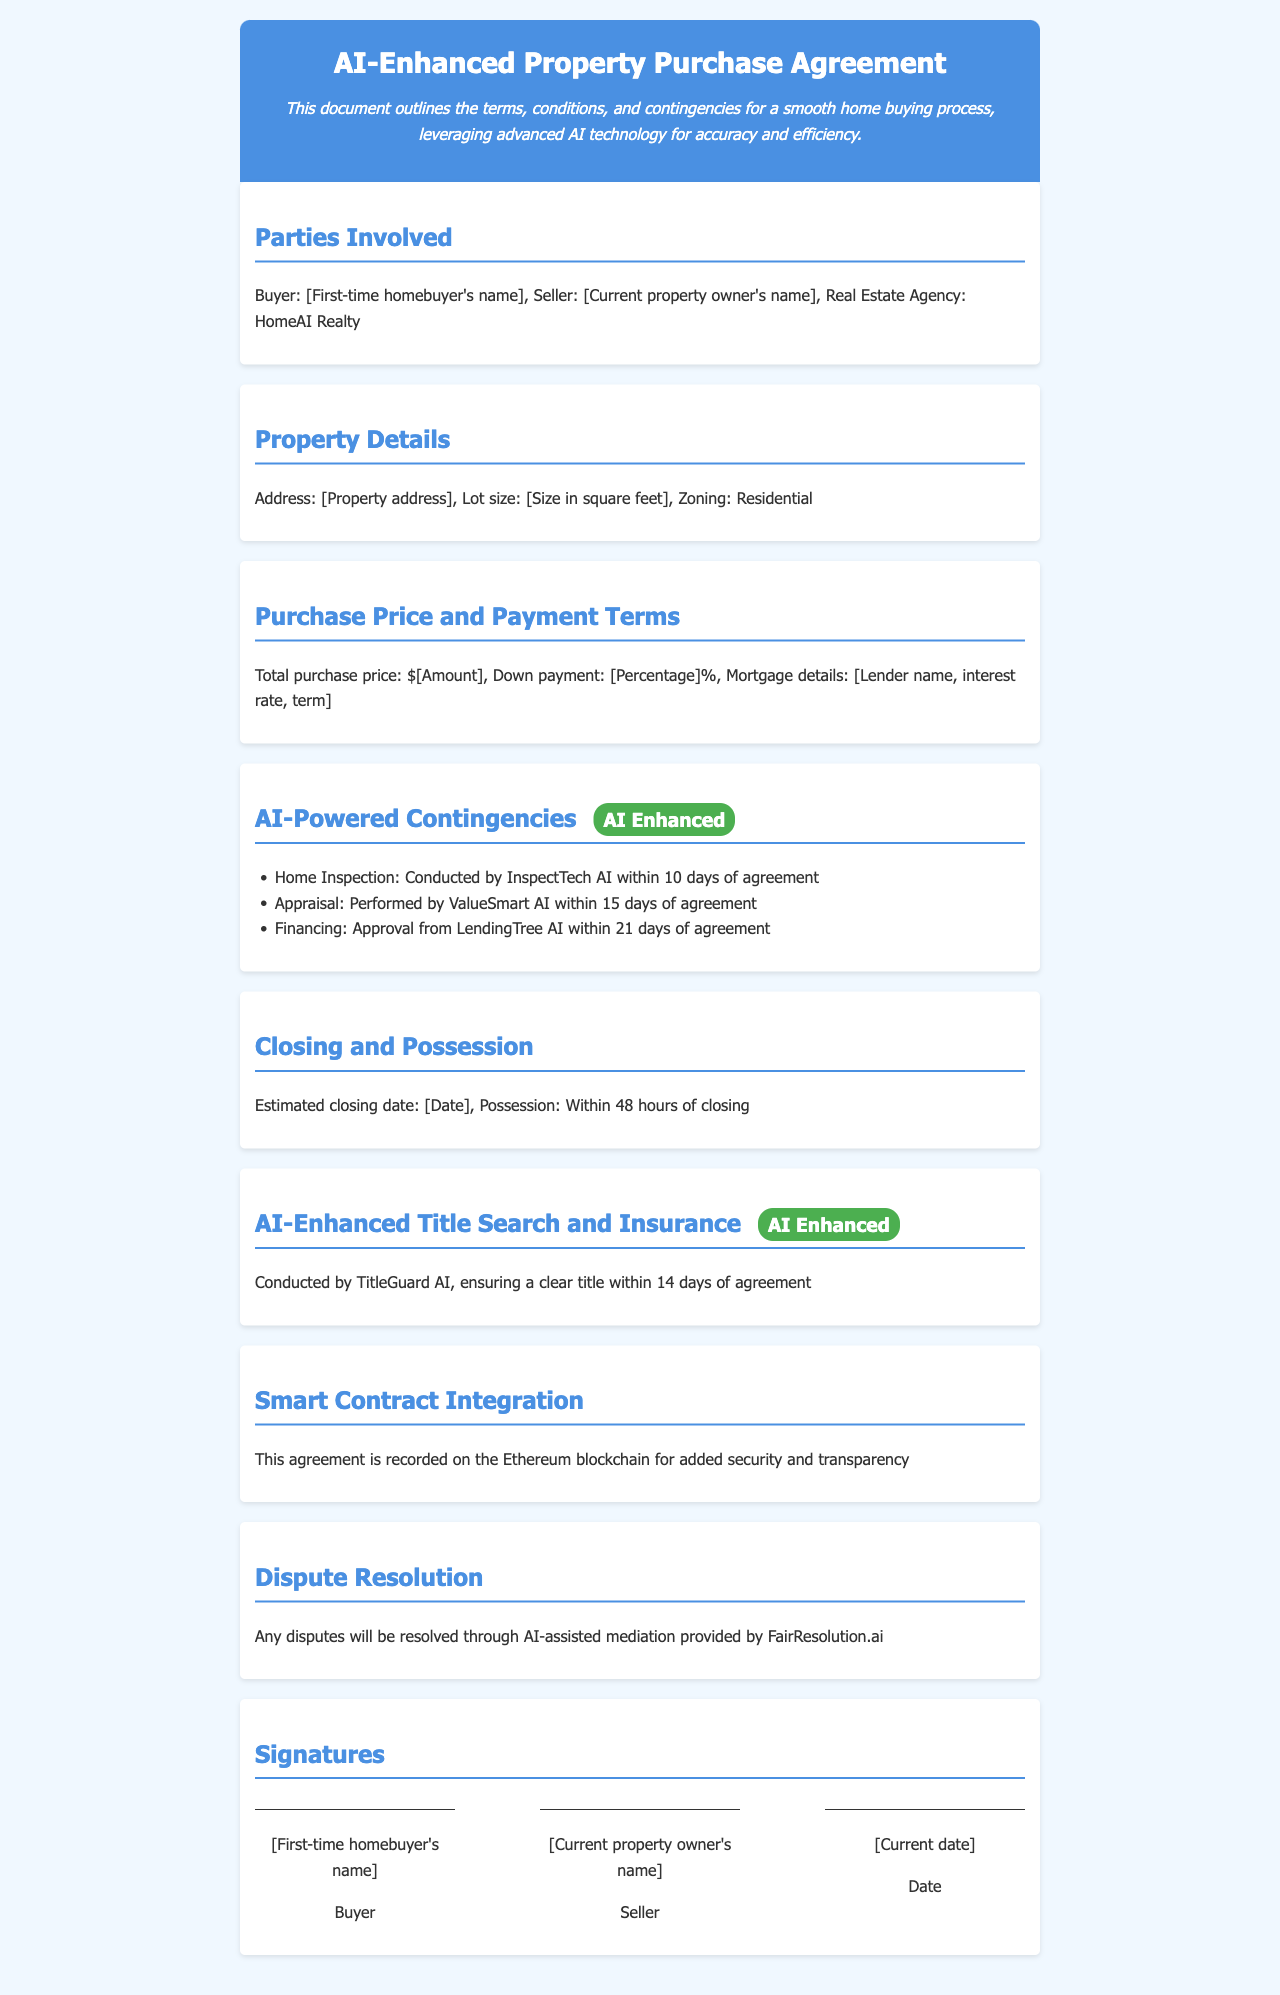What is the buyer's name? The document mentions the buyer as "[First-time homebuyer's name]", indicating the identity of the buyer.
Answer: [First-time homebuyer's name] What is the purchase price? It specifies the total purchase price as "$[Amount]", indicating that this will vary based on the specific transaction.
Answer: $[Amount] How many days for the home inspection? The contingency section specifies that the home inspection is to be conducted within 10 days of the agreement.
Answer: 10 days Who conducts the title search? The document states that TitleGuard AI conducts the title search, indicating who is responsible for this task.
Answer: TitleGuard AI What date is estimated for closing? The document mentions the estimated closing date as "[Date]", indicating that it is yet to be determined.
Answer: [Date] What happens if disputes arise? The document outlines that disputes will be resolved through AI-assisted mediation provided by FairResolution.ai, indicating the approach to dispute resolution.
Answer: AI-assisted mediation What is the zoning of the property? The zoning of the property is noted as "Residential" in the property details section.
Answer: Residential How long is the loan approval process? It states that financing approval is to be obtained within 21 days of the agreement, highlighting the timeframe for loan approval.
Answer: 21 days What technology is used for contract security? The agreement states that it is recorded on the Ethereum blockchain for added security, indicating the use of advanced technology for this purpose.
Answer: Ethereum blockchain 